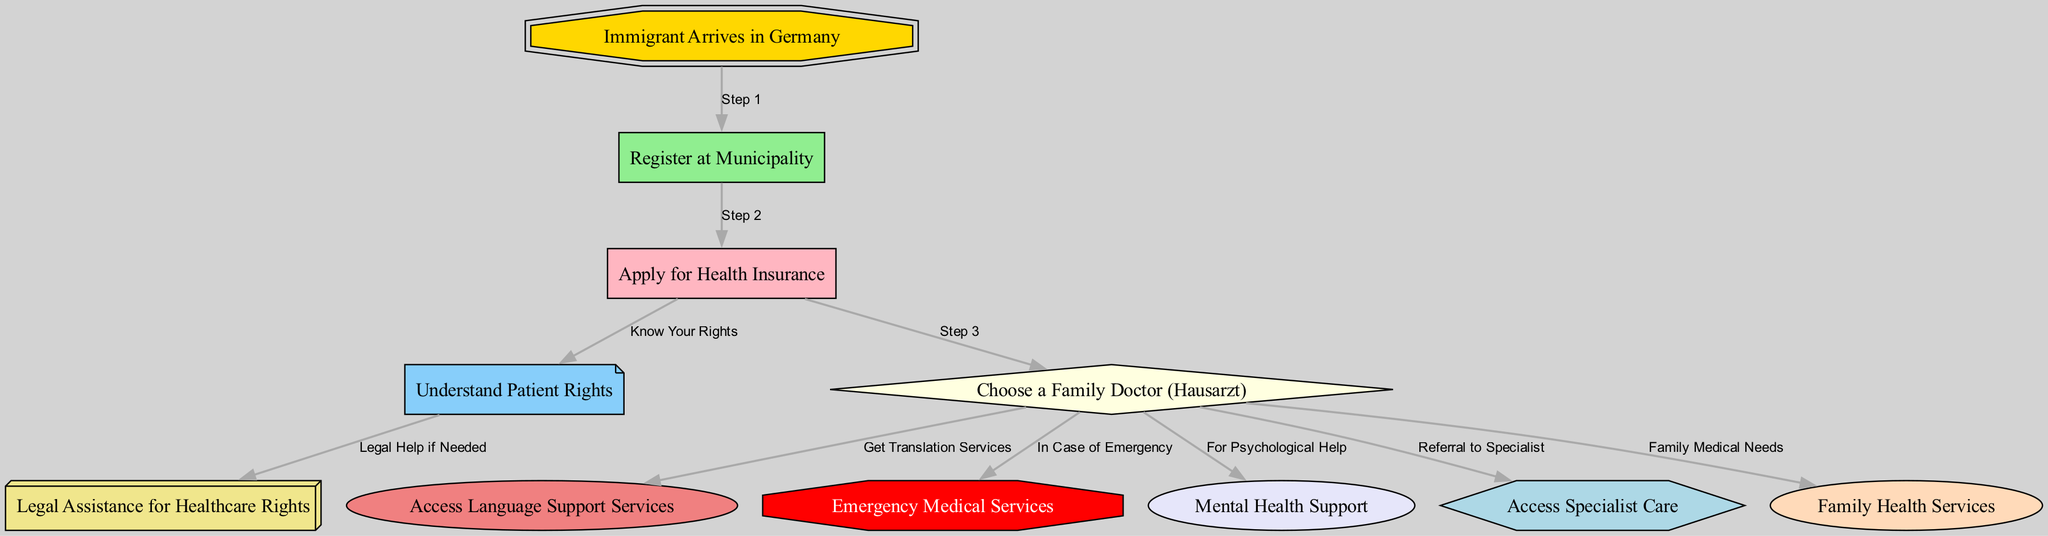What is the first step an immigrant must take upon arriving in Germany? The diagram indicates that the first step after an immigrant's arrival is to "Register at Municipality." This is represented as the first node in the flow of services provided.
Answer: Register at Municipality How many support services are available after choosing a family doctor? Upon examining the flowchart, there are five services accessible after the "Choose a Family Doctor" node: language support, emergency services, mental health support, specialist care, and family health services. By counting these connections, we can conclude the total.
Answer: 5 What should an immigrant do to understand their healthcare rights? The diagram specifies that to comprehend patient rights, an immigrant should follow the path from "Health Insurance" to "Understand Patient Rights." This indicates a direct relationship where knowing about health insurance leads to the understanding of rights.
Answer: Understand Patient Rights How does the patient rights node connect to legal assistance? Looking at the diagram, the connection is a single directed edge leading from the "Understand Patient Rights" node to "Legal Assistance for Healthcare Rights." This indicates that understanding your rights may require legal help if there are issues.
Answer: Legal Assistance for Healthcare Rights What color is the node representing mental health support? By observing the diagram, the "Mental Health Support" node is depicted in lavender. This color specifically is designated for this service, differentiating it from other health services provided in the diagram.
Answer: Lavender What is necessary to access translation services? The flow indicates that in order to access language support services, an immigrant must first "Choose a Family Doctor." This necessitates this choice as a prerequisite to obtaining translation services.
Answer: Choose a Family Doctor Which step comes after applying for health insurance? According to the flow, the step following the "Apply for Health Insurance" node is "Choose a Family Doctor." Thus, there is a straightforward sequence indicating healthcare procedures in Germany.
Answer: Choose a Family Doctor What services can an immigrant access in case of an emergency? The diagram shows that upon choosing a family doctor, an immigrant can access "Emergency Medical Services." This connection highlights the importance of having designated pathways for urgent care.
Answer: Emergency Medical Services How does an immigrant access specialist care? The diagram illustrates that after choosing a family doctor, an immigrant can access "Specialist Care" through a referral. This shows that obtaining specialist services involves an intermediary step of consultation with a family doctor.
Answer: Referral to Specialist 